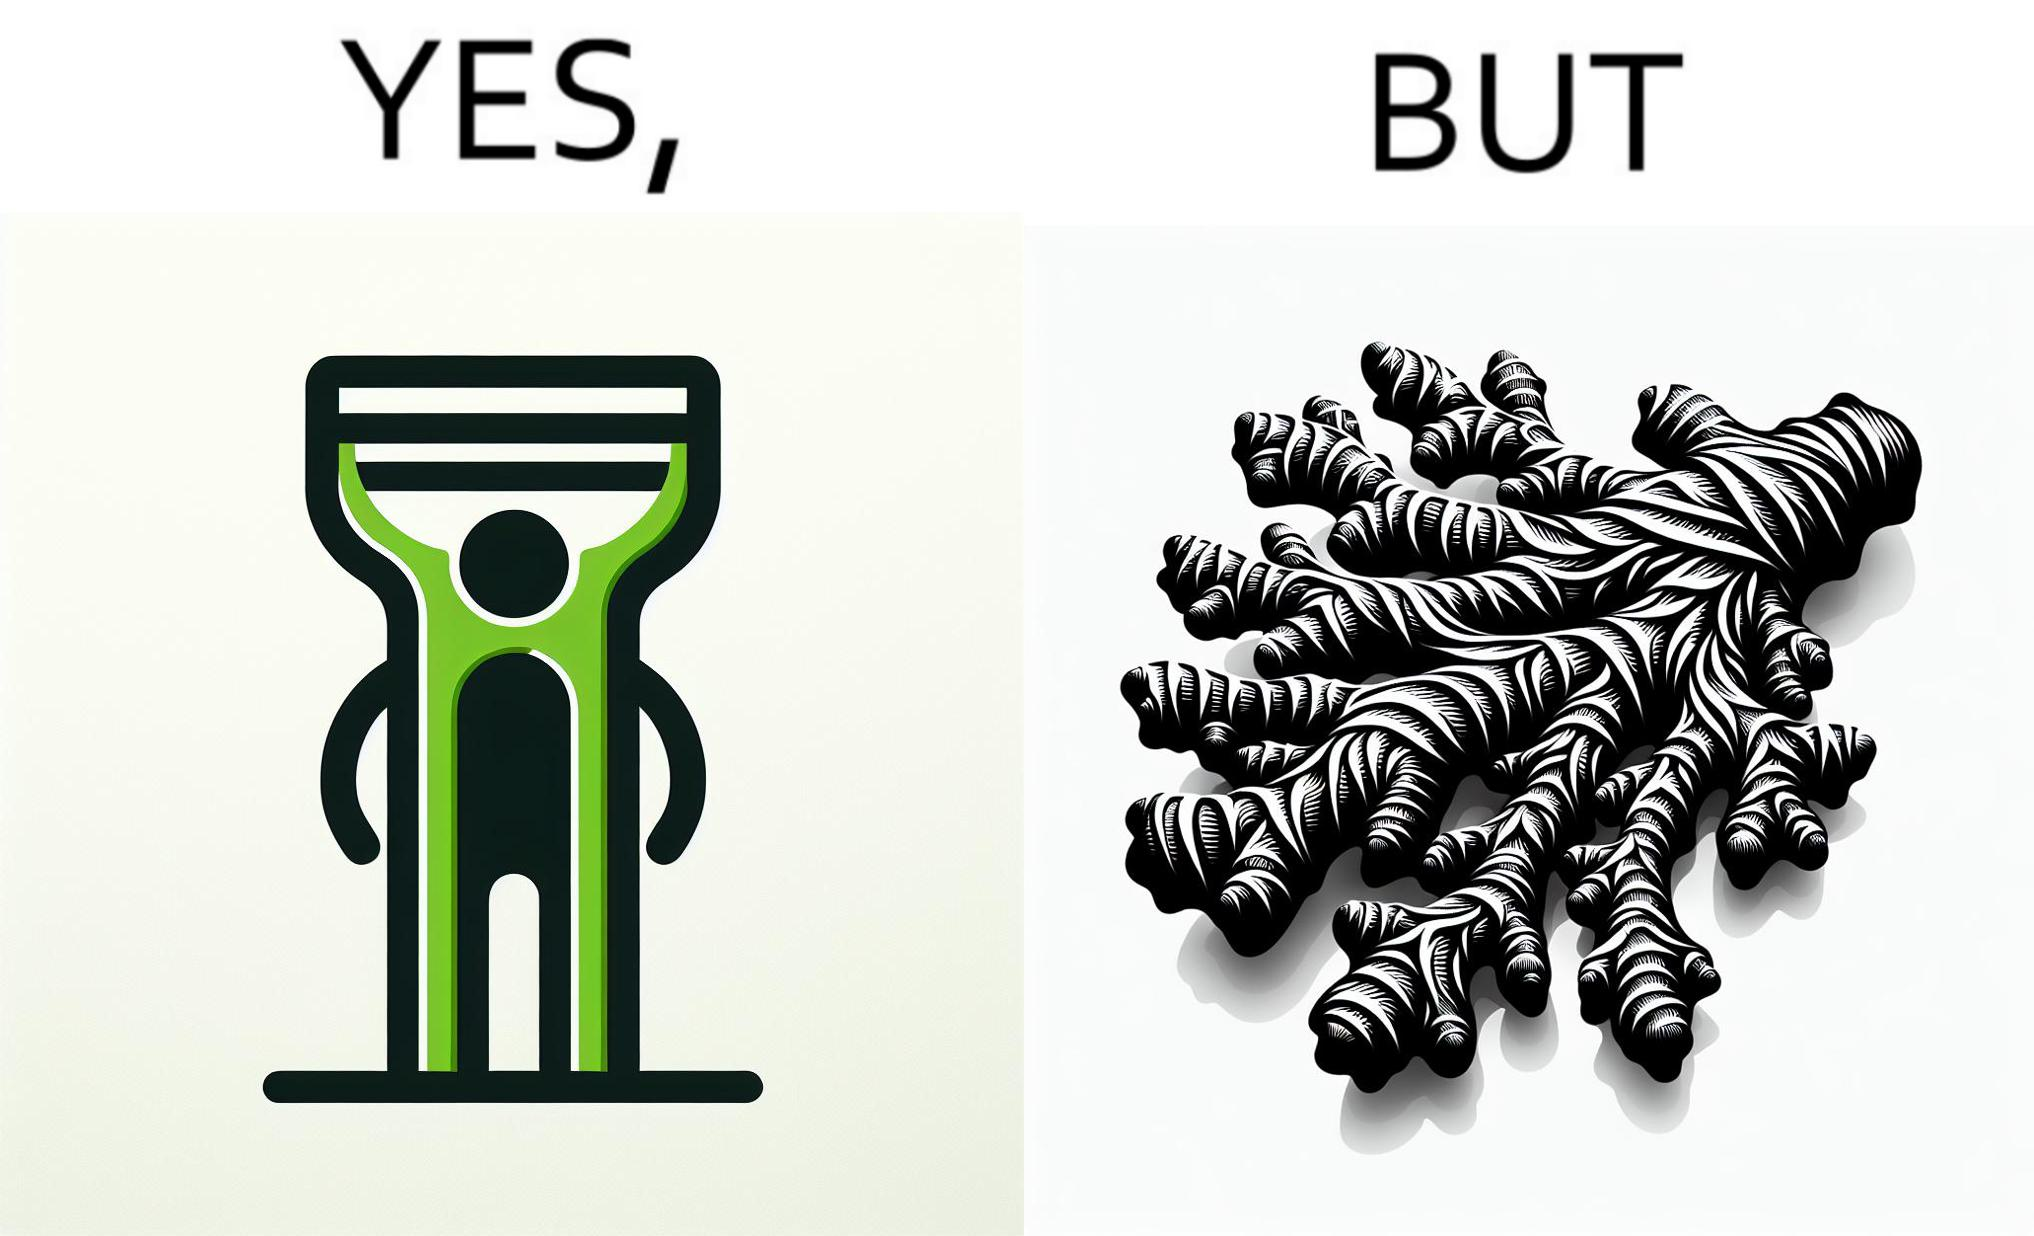Provide a description of this image. The image is funny because it suggests that while we have peelers to peel off the skin of many different fruits and vegetables, it is useless against a ginger which has a very complicated shape. 